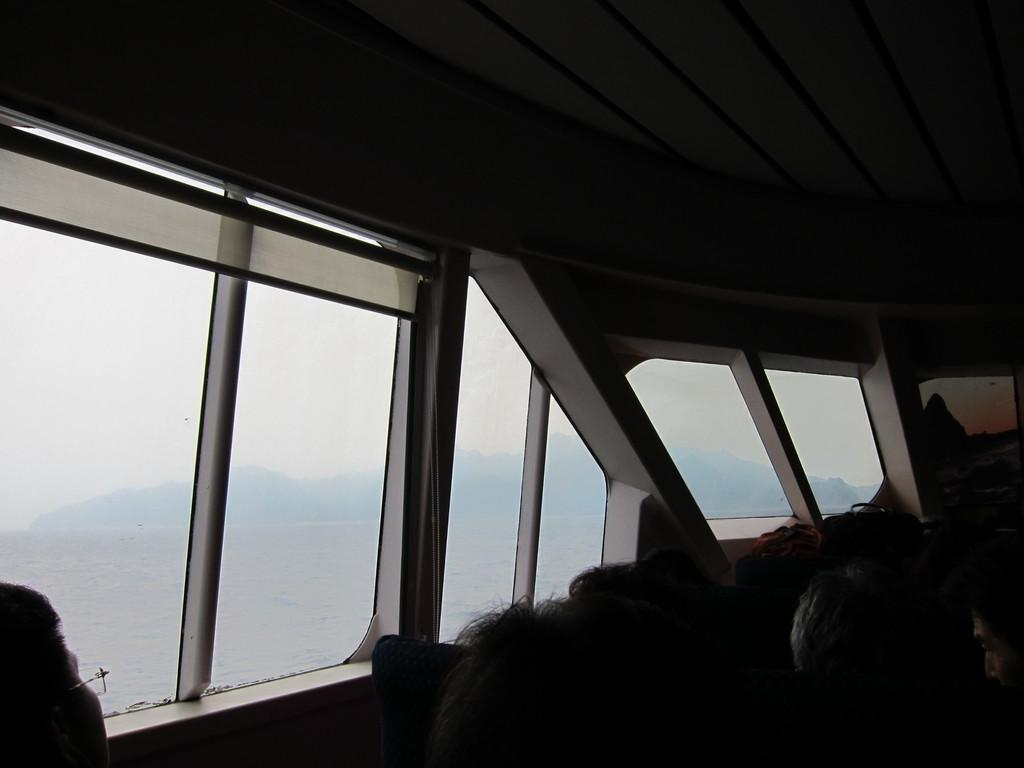Who or what can be seen at the bottom side of the image? There are people at the bottom side of the image. What architectural feature is present on the left side of the image? There are windows on the left side of the image. What time of day is the surprise taking place in the image? There is no mention of a surprise or any specific time of day in the image. 